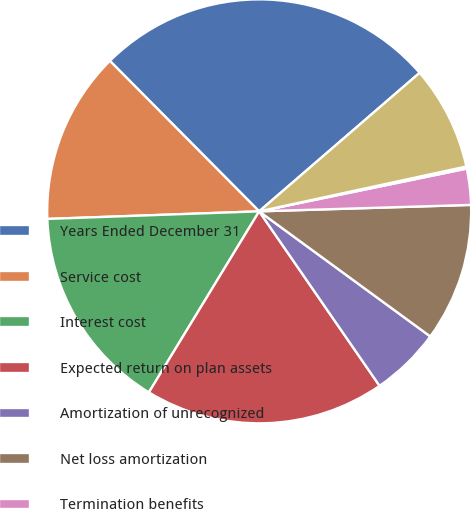Convert chart to OTSL. <chart><loc_0><loc_0><loc_500><loc_500><pie_chart><fcel>Years Ended December 31<fcel>Service cost<fcel>Interest cost<fcel>Expected return on plan assets<fcel>Amortization of unrecognized<fcel>Net loss amortization<fcel>Termination benefits<fcel>Curtailments<fcel>Net periodic benefit cost<nl><fcel>26.1%<fcel>13.13%<fcel>15.72%<fcel>18.32%<fcel>5.34%<fcel>10.53%<fcel>2.75%<fcel>0.16%<fcel>7.94%<nl></chart> 